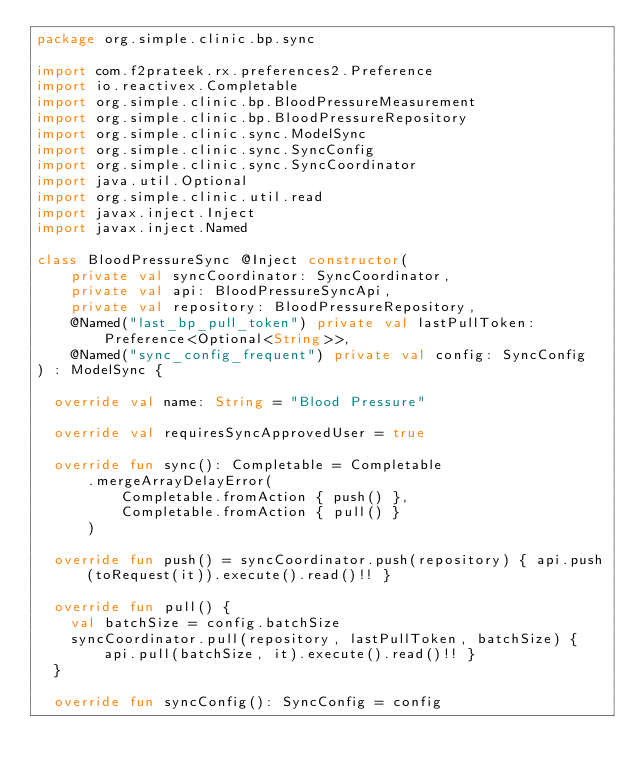<code> <loc_0><loc_0><loc_500><loc_500><_Kotlin_>package org.simple.clinic.bp.sync

import com.f2prateek.rx.preferences2.Preference
import io.reactivex.Completable
import org.simple.clinic.bp.BloodPressureMeasurement
import org.simple.clinic.bp.BloodPressureRepository
import org.simple.clinic.sync.ModelSync
import org.simple.clinic.sync.SyncConfig
import org.simple.clinic.sync.SyncCoordinator
import java.util.Optional
import org.simple.clinic.util.read
import javax.inject.Inject
import javax.inject.Named

class BloodPressureSync @Inject constructor(
    private val syncCoordinator: SyncCoordinator,
    private val api: BloodPressureSyncApi,
    private val repository: BloodPressureRepository,
    @Named("last_bp_pull_token") private val lastPullToken: Preference<Optional<String>>,
    @Named("sync_config_frequent") private val config: SyncConfig
) : ModelSync {

  override val name: String = "Blood Pressure"

  override val requiresSyncApprovedUser = true

  override fun sync(): Completable = Completable
      .mergeArrayDelayError(
          Completable.fromAction { push() },
          Completable.fromAction { pull() }
      )

  override fun push() = syncCoordinator.push(repository) { api.push(toRequest(it)).execute().read()!! }

  override fun pull() {
    val batchSize = config.batchSize
    syncCoordinator.pull(repository, lastPullToken, batchSize) { api.pull(batchSize, it).execute().read()!! }
  }

  override fun syncConfig(): SyncConfig = config
</code> 